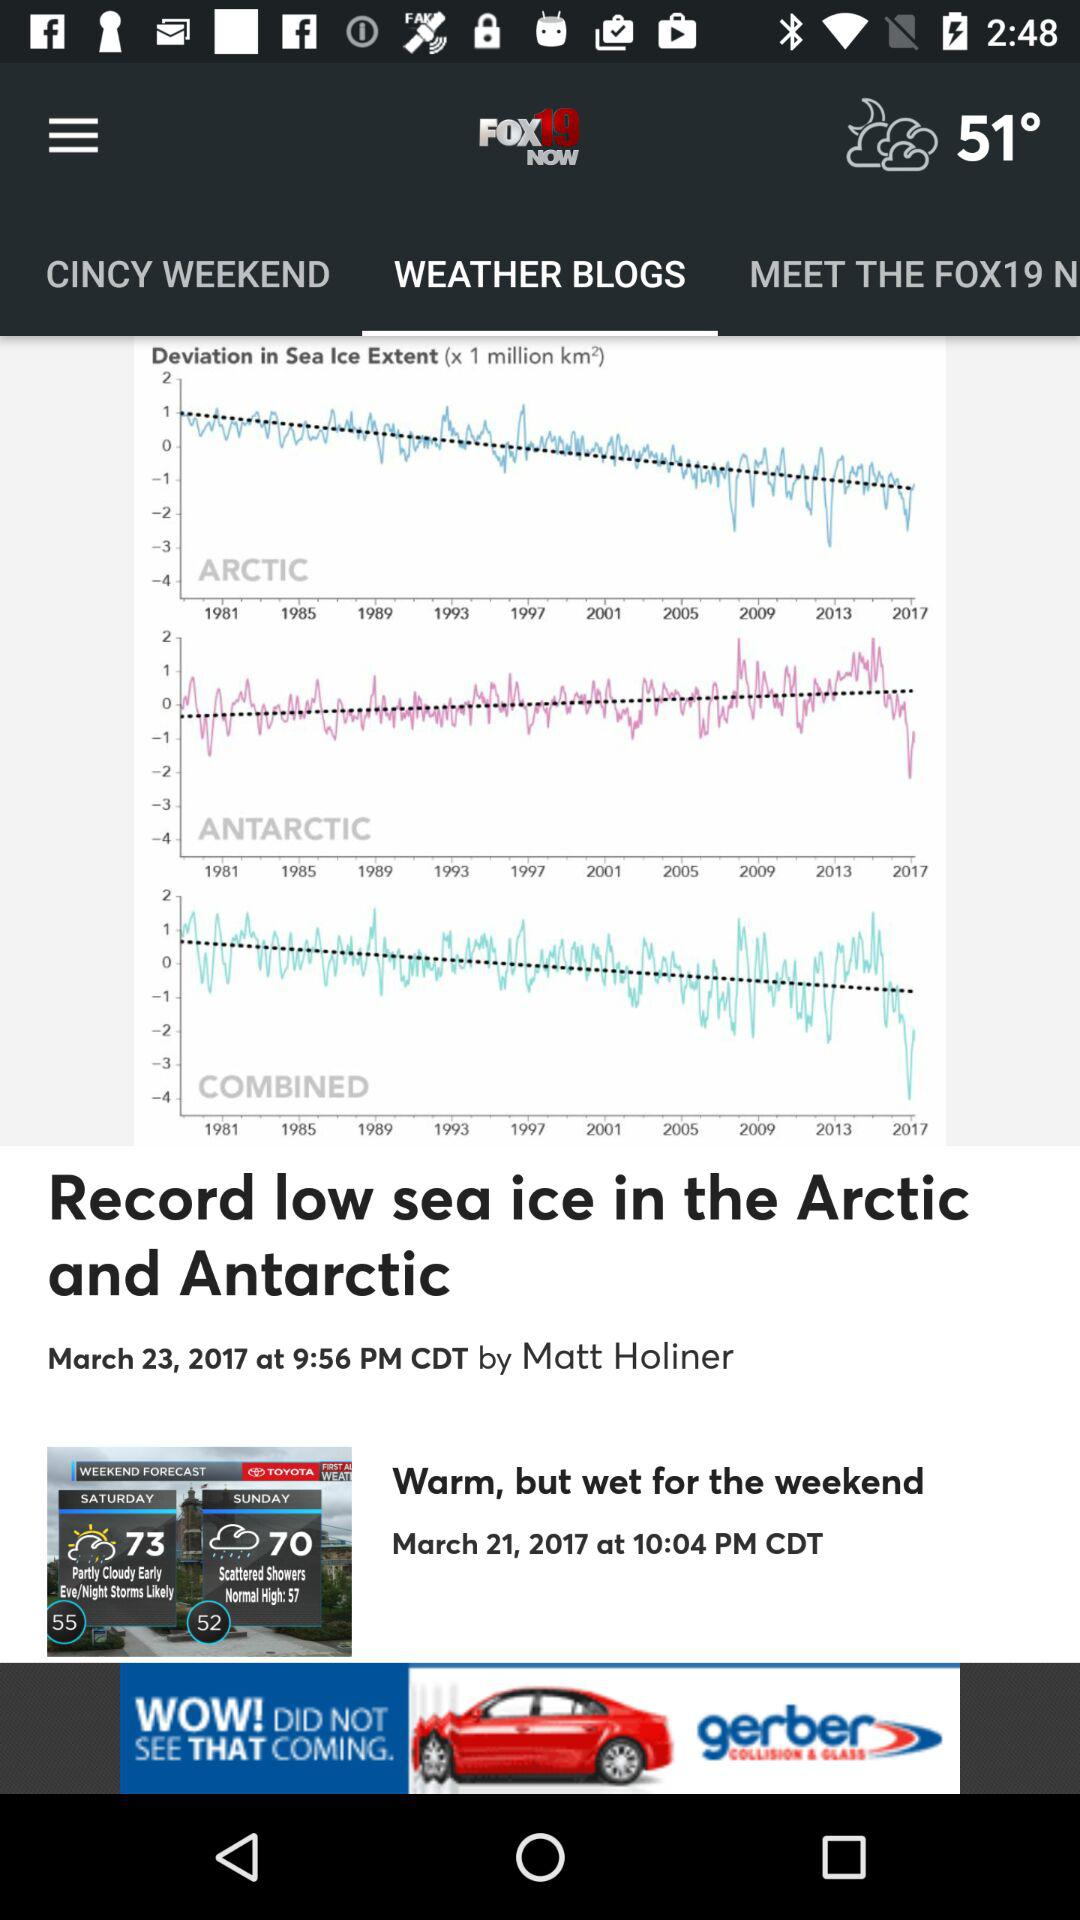What kind of website or source is depicted in the image? The image features a screenshot of what appears to be a weather-related website, possibly a news outlet's weather blog given the presence of articles, a forecast, and related posts. This kind of website often provides valuable information on current weather conditions, forecasts, and noteworthy climate trends or events. How reliable would this source be for research or detailed climate analysis? While such a website can be a helpful starting point for the general public to stay updated on weather and climate topics, for in-depth research or analysis, scientists and experts typically refer to peer-reviewed studies, official datasets, and government or institutional resources that offer comprehensive, validated data and analyses. 